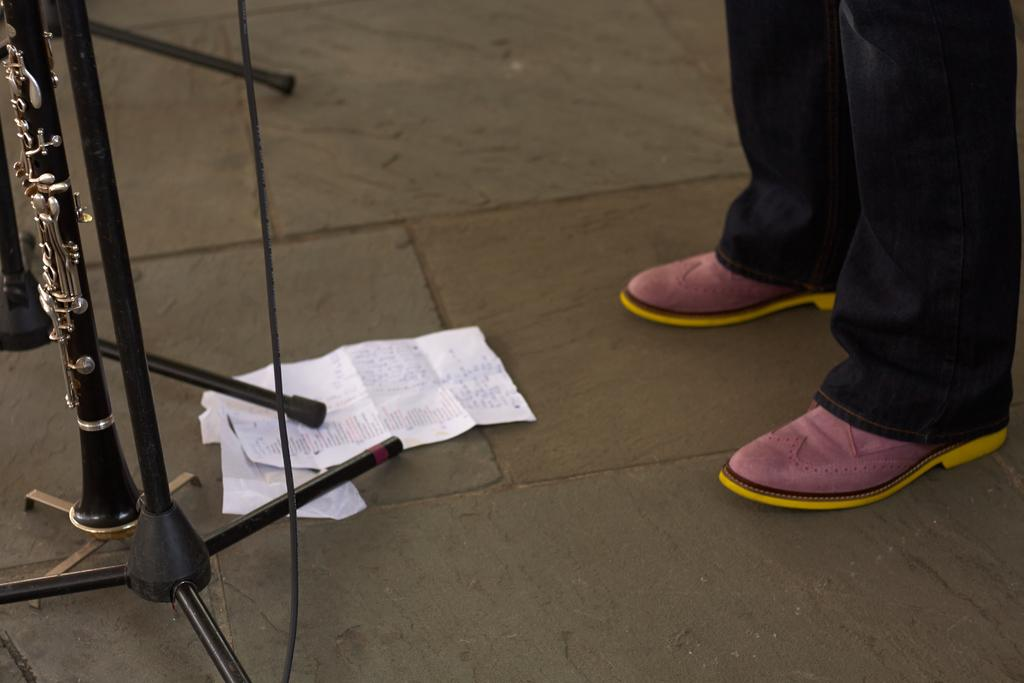What type of surface is visible in the image? There is ground visible in the image. What structures are present on the ground? There are stands on the ground. What type of objects can be seen in the image? There are papers in the image. Can you describe any human presence in the image? The legs of a person are visible in the image. What type of argument is taking place between the father and the child in the image? There is no father or child present in the image, and therefore no argument can be observed. 